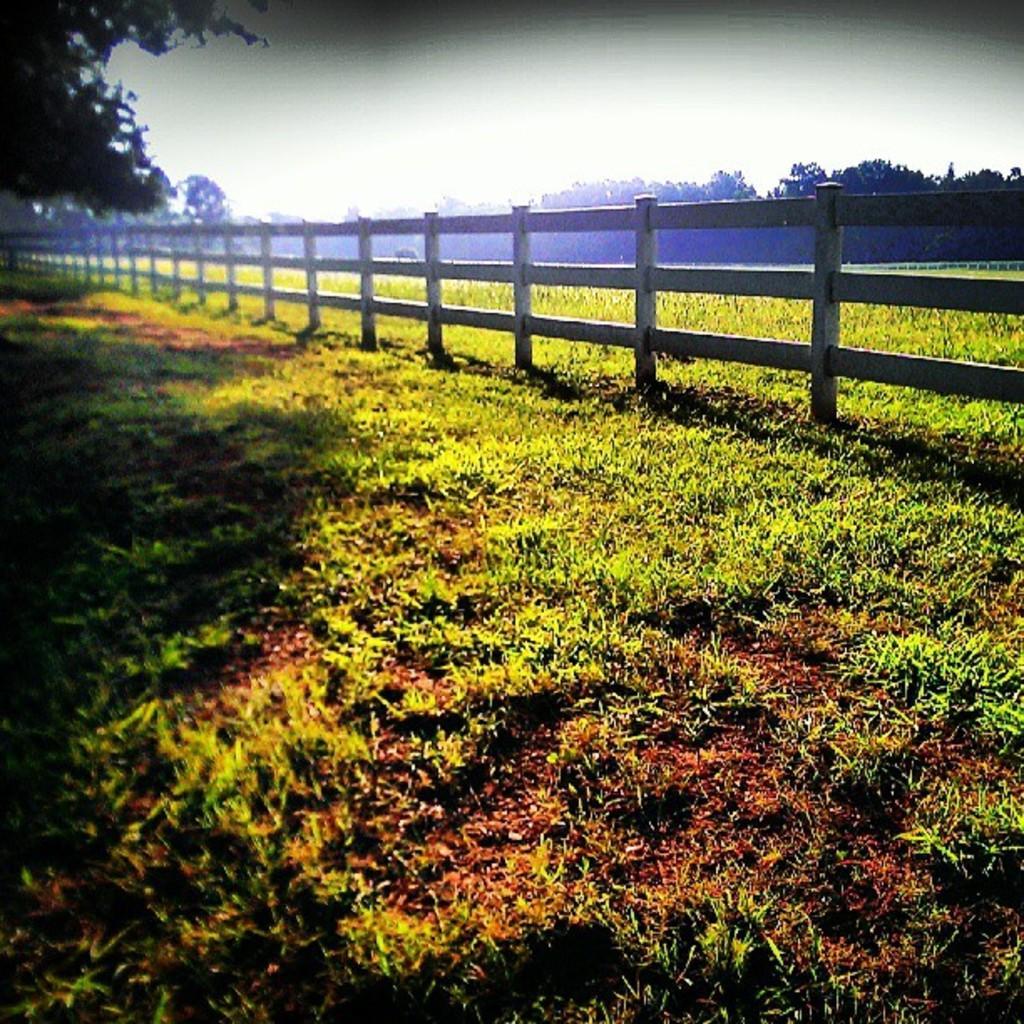Describe this image in one or two sentences. In the center of the image there is a metal fence. At the bottom of the image there is grass on the surface. In the background of the image there are trees and sky. 